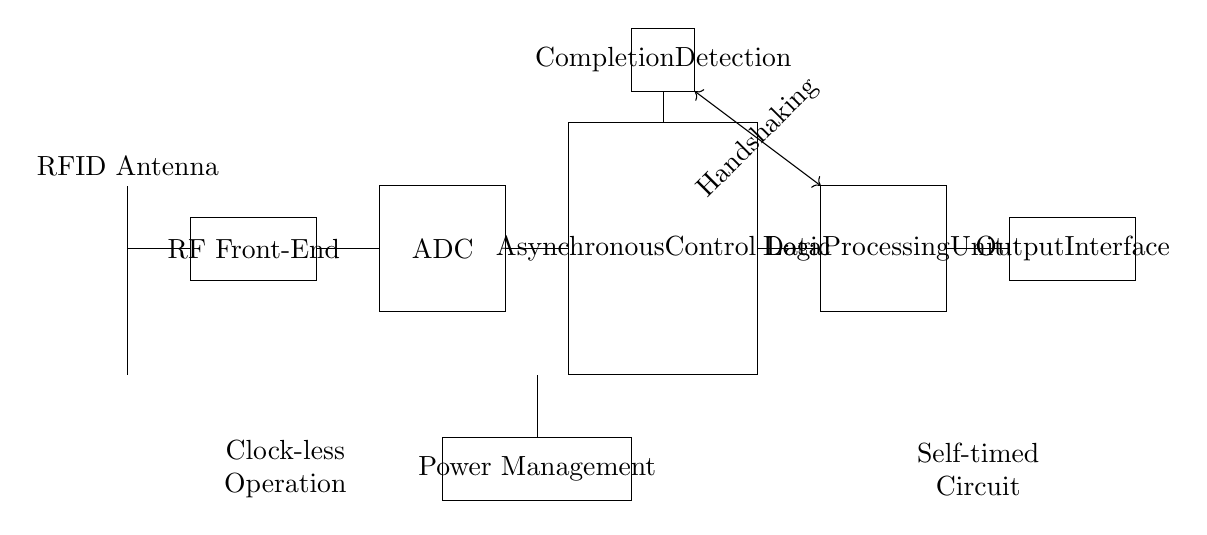What are the main components in this circuit? The main components are the RFID Antenna, RF Front-End, ADC, Asynchronous Control Logic, Data Processing Unit, Output Interface, Power Management, Completion Detection. These components play pivotal roles in the reading and processing of RFID signals.
Answer: RFID Antenna, RF Front-End, ADC, Asynchronous Control Logic, Data Processing Unit, Output Interface, Power Management, Completion Detection What type of operation does the circuit perform? The circuit performs a self-timed operation, as denoted in the notes at the bottom of the diagram. This means it operates without relying on a clock signal, which allows for faster processing and efficiency.
Answer: Self-timed What is the function of the Asynchronous Control Logic? The function of the Asynchronous Control Logic is to manage the operation of various circuit components without the need for a clock signal, enabling quicker response times and smoother operation.
Answer: Manage circuit operations What type of signal is used for communication between components? Handshaking signals are used for communication between components. Handshaking allows the components to coordinate their actions and ensure that data is communicated effectively.
Answer: Handshaking signals What is the purpose of the Completion Detection component? The Completion Detection component is used to identify when the data processing is complete, signaling other parts of the circuit to proceed with their tasks, which is crucial for maintaining efficient workflows.
Answer: Identify data completion How many main functional blocks are in this circuit? There are six main functional blocks in this circuit: RFID Antenna, RF Front-End, ADC, Asynchronous Control Logic, Data Processing Unit, and Output Interface. Each block serves a distinct purpose in the overall operation.
Answer: Six What is indicated by the "Clock-less Operation" note? The note "Clock-less Operation" indicates that this circuit does not require a clock signal for its operations, which contrasts traditional synchronous circuits and allows for potentially faster performance.
Answer: Indicates no clock signal required 